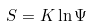Convert formula to latex. <formula><loc_0><loc_0><loc_500><loc_500>S = K \ln \Psi</formula> 